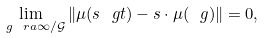<formula> <loc_0><loc_0><loc_500><loc_500>\lim _ { \ g \ r a \infty / \mathcal { G } } \| \mu ( s \ g t ) - s \cdot \mu ( \ g ) \| = 0 ,</formula> 